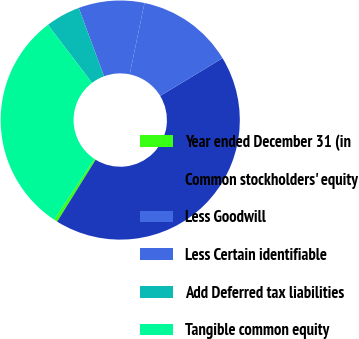Convert chart to OTSL. <chart><loc_0><loc_0><loc_500><loc_500><pie_chart><fcel>Year ended December 31 (in<fcel>Common stockholders' equity<fcel>Less Goodwill<fcel>Less Certain identifiable<fcel>Add Deferred tax liabilities<fcel>Tangible common equity<nl><fcel>0.49%<fcel>42.5%<fcel>13.09%<fcel>8.89%<fcel>4.69%<fcel>30.33%<nl></chart> 